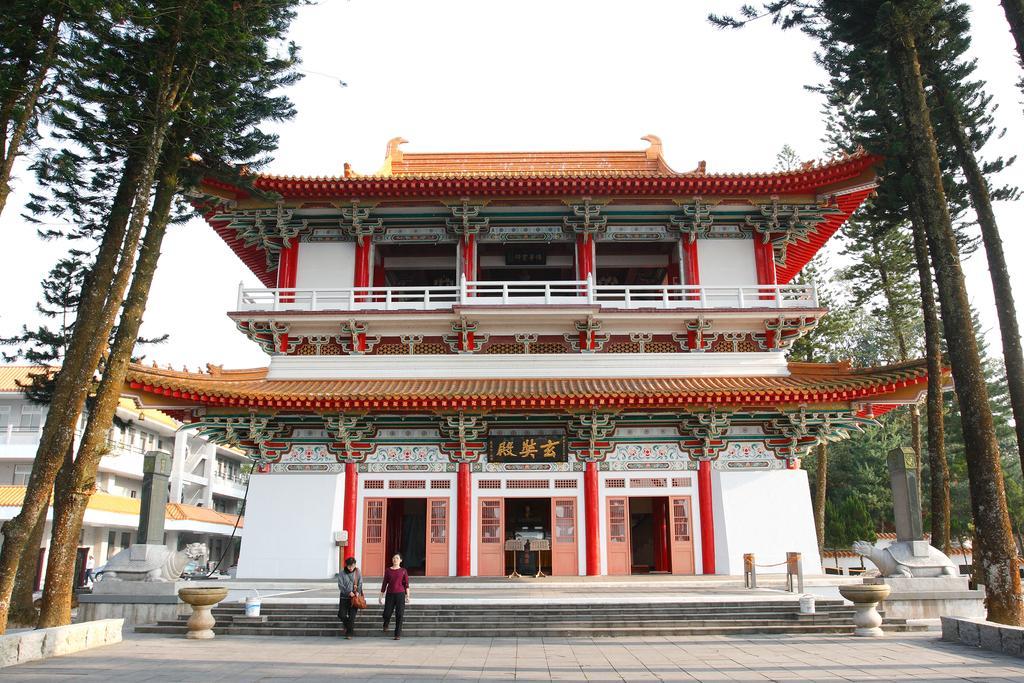Please provide a concise description of this image. At the center of the image there are buildings. In front of the building there are two persons walking on the floor. In the background there are trees and sky. 